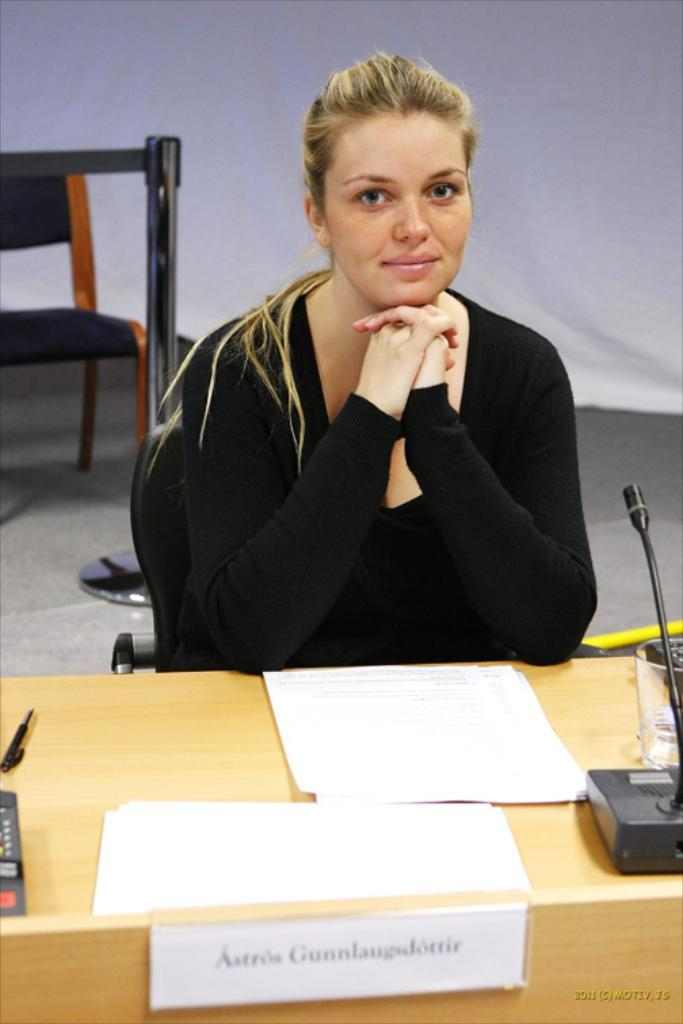What is the person in the image doing? The person is sitting on a chair in the image. What object is visible near the person? There is a microphone in the image. What is on the table in the image? There are papers and other objects on a table in the image. Can you describe the chair in the background of the image? There is a chair in the background of the image. What book is the person reading in the image? There is no book present in the image; the person is sitting on a chair with a microphone nearby. 